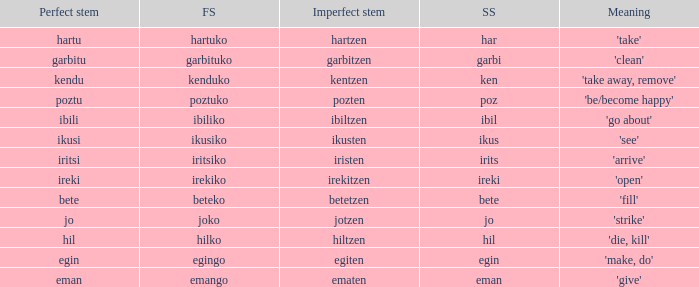What is the perfect stem for pozten? Poztu. 